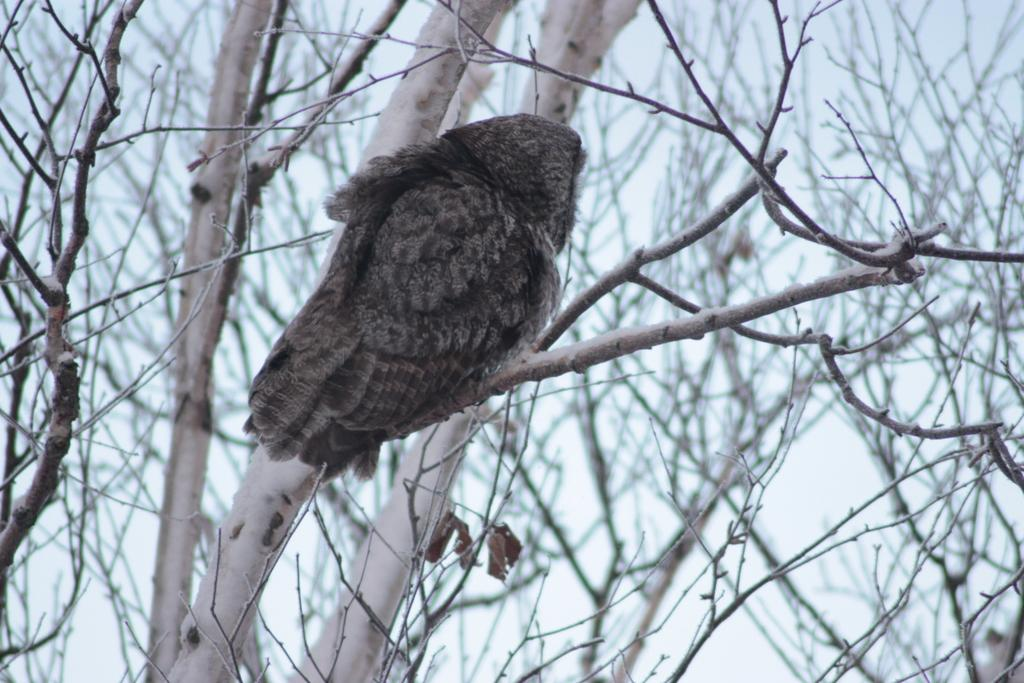What type of animal is present in the image? There is a bird in the image. Can you describe the bird's location in the image? The bird is on a dry tree. What type of trousers is the bird wearing in the image? The bird is not wearing any trousers in the image, as birds do not wear clothing. 